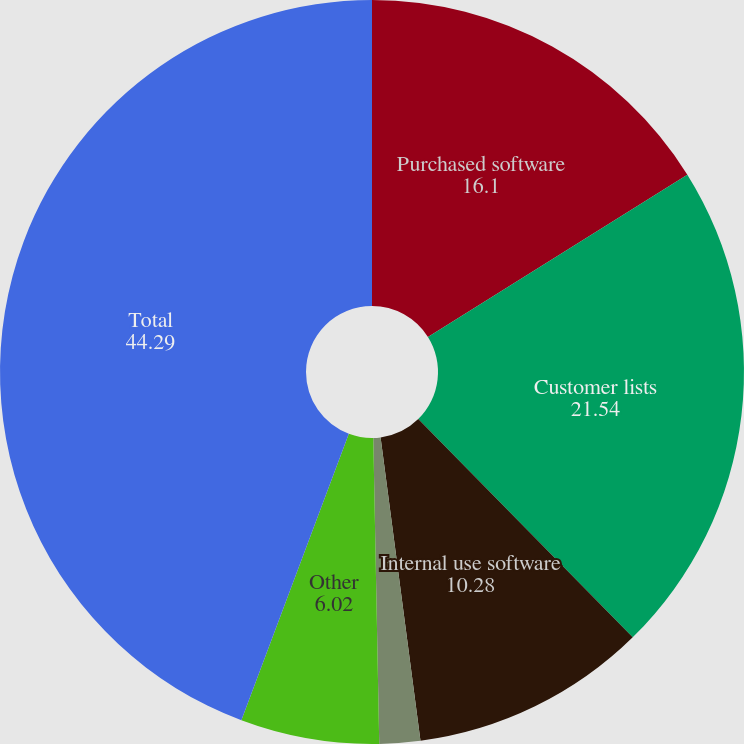<chart> <loc_0><loc_0><loc_500><loc_500><pie_chart><fcel>Purchased software<fcel>Customer lists<fcel>Internal use software<fcel>Trade names<fcel>Other<fcel>Total<nl><fcel>16.1%<fcel>21.54%<fcel>10.28%<fcel>1.77%<fcel>6.02%<fcel>44.29%<nl></chart> 